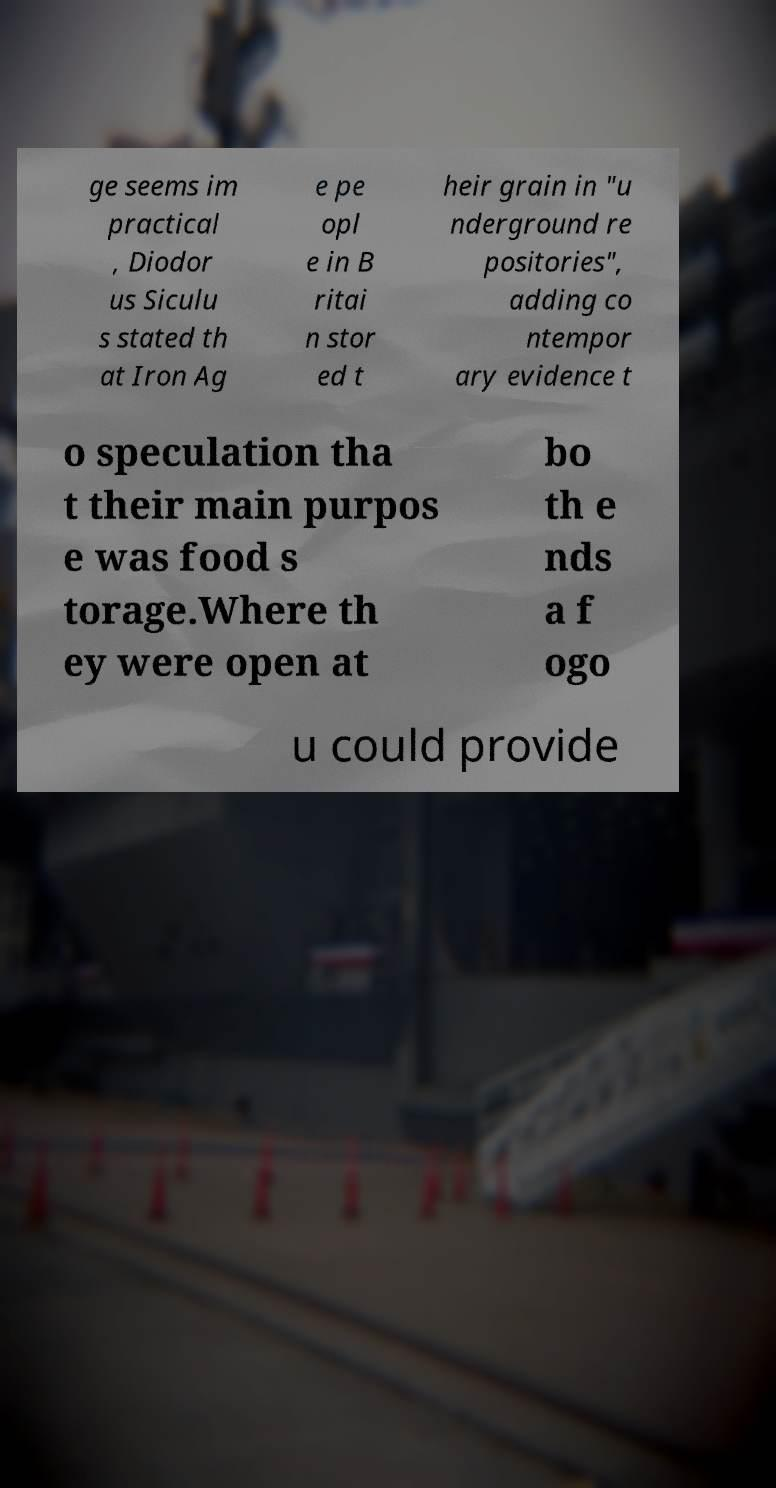I need the written content from this picture converted into text. Can you do that? ge seems im practical , Diodor us Siculu s stated th at Iron Ag e pe opl e in B ritai n stor ed t heir grain in "u nderground re positories", adding co ntempor ary evidence t o speculation tha t their main purpos e was food s torage.Where th ey were open at bo th e nds a f ogo u could provide 